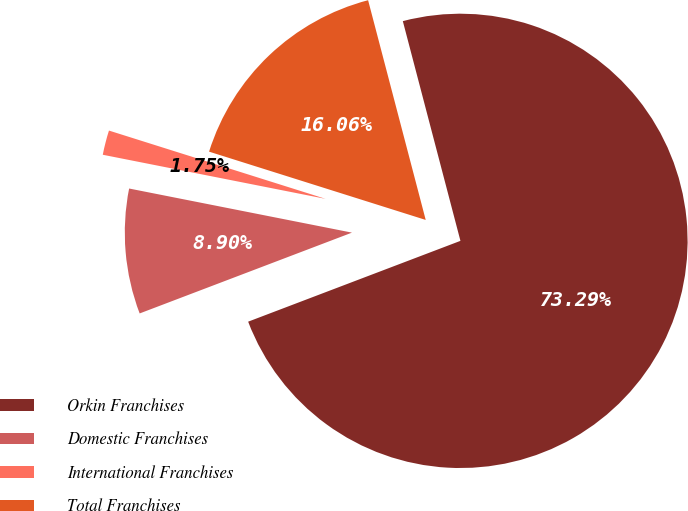Convert chart to OTSL. <chart><loc_0><loc_0><loc_500><loc_500><pie_chart><fcel>Orkin Franchises<fcel>Domestic Franchises<fcel>International Franchises<fcel>Total Franchises<nl><fcel>73.3%<fcel>8.9%<fcel>1.75%<fcel>16.06%<nl></chart> 